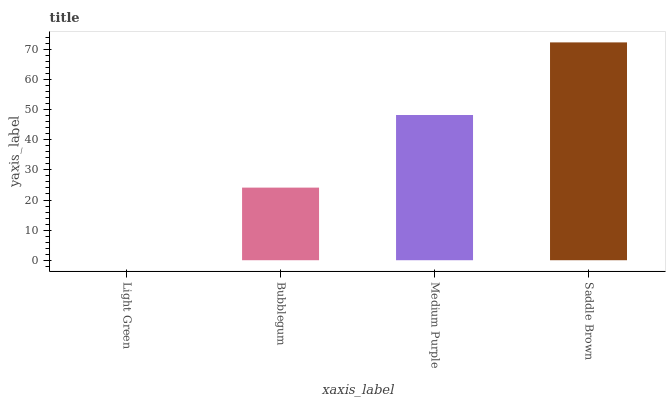Is Light Green the minimum?
Answer yes or no. Yes. Is Saddle Brown the maximum?
Answer yes or no. Yes. Is Bubblegum the minimum?
Answer yes or no. No. Is Bubblegum the maximum?
Answer yes or no. No. Is Bubblegum greater than Light Green?
Answer yes or no. Yes. Is Light Green less than Bubblegum?
Answer yes or no. Yes. Is Light Green greater than Bubblegum?
Answer yes or no. No. Is Bubblegum less than Light Green?
Answer yes or no. No. Is Medium Purple the high median?
Answer yes or no. Yes. Is Bubblegum the low median?
Answer yes or no. Yes. Is Bubblegum the high median?
Answer yes or no. No. Is Medium Purple the low median?
Answer yes or no. No. 